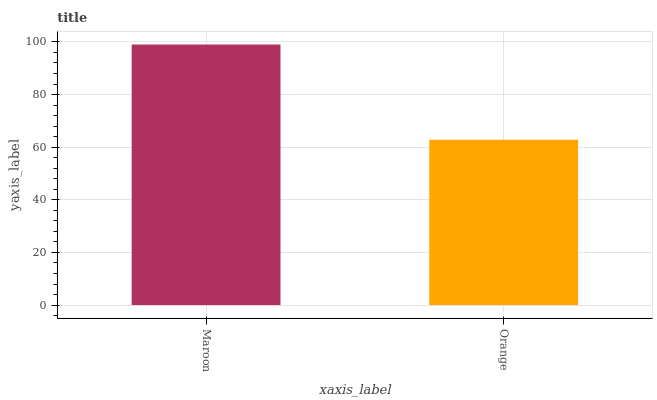Is Orange the minimum?
Answer yes or no. Yes. Is Maroon the maximum?
Answer yes or no. Yes. Is Orange the maximum?
Answer yes or no. No. Is Maroon greater than Orange?
Answer yes or no. Yes. Is Orange less than Maroon?
Answer yes or no. Yes. Is Orange greater than Maroon?
Answer yes or no. No. Is Maroon less than Orange?
Answer yes or no. No. Is Maroon the high median?
Answer yes or no. Yes. Is Orange the low median?
Answer yes or no. Yes. Is Orange the high median?
Answer yes or no. No. Is Maroon the low median?
Answer yes or no. No. 